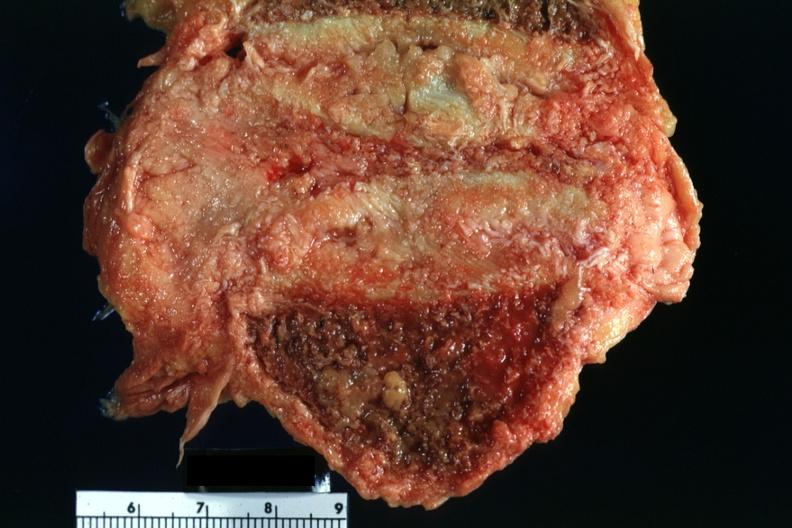s joints present?
Answer the question using a single word or phrase. Yes 